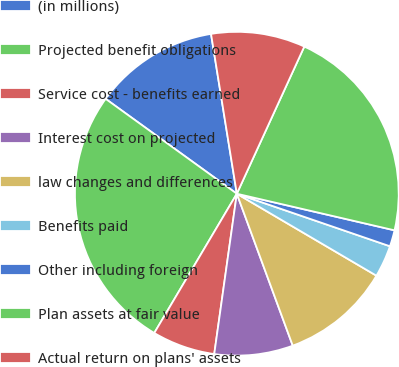Convert chart to OTSL. <chart><loc_0><loc_0><loc_500><loc_500><pie_chart><fcel>(in millions)<fcel>Projected benefit obligations<fcel>Service cost - benefits earned<fcel>Interest cost on projected<fcel>law changes and differences<fcel>Benefits paid<fcel>Other including foreign<fcel>Plan assets at fair value<fcel>Actual return on plans' assets<nl><fcel>12.49%<fcel>26.45%<fcel>6.29%<fcel>7.84%<fcel>10.94%<fcel>3.19%<fcel>1.63%<fcel>21.79%<fcel>9.39%<nl></chart> 